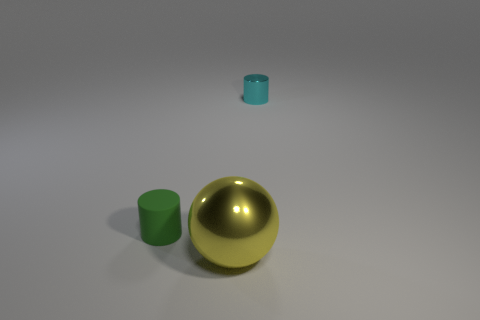Is the large yellow thing made of the same material as the cylinder that is left of the big metallic sphere?
Keep it short and to the point. No. There is a thing that is behind the big metallic object and in front of the cyan thing; what material is it made of?
Keep it short and to the point. Rubber. There is a cylinder to the left of the metallic thing left of the tiny cyan thing; what color is it?
Offer a terse response. Green. There is a tiny thing that is to the left of the yellow shiny ball; what is it made of?
Provide a succinct answer. Rubber. Is the number of gray shiny cubes less than the number of spheres?
Your response must be concise. Yes. Do the small cyan metal thing and the tiny object that is on the left side of the yellow metal ball have the same shape?
Offer a very short reply. Yes. There is a object that is both behind the large yellow sphere and right of the matte thing; what is its shape?
Provide a short and direct response. Cylinder. Are there the same number of cyan cylinders that are behind the large sphere and small cyan metal things behind the small matte thing?
Offer a terse response. Yes. Does the metallic thing that is left of the tiny shiny cylinder have the same shape as the green thing?
Offer a very short reply. No. How many purple things are big objects or large matte things?
Your answer should be very brief. 0. 